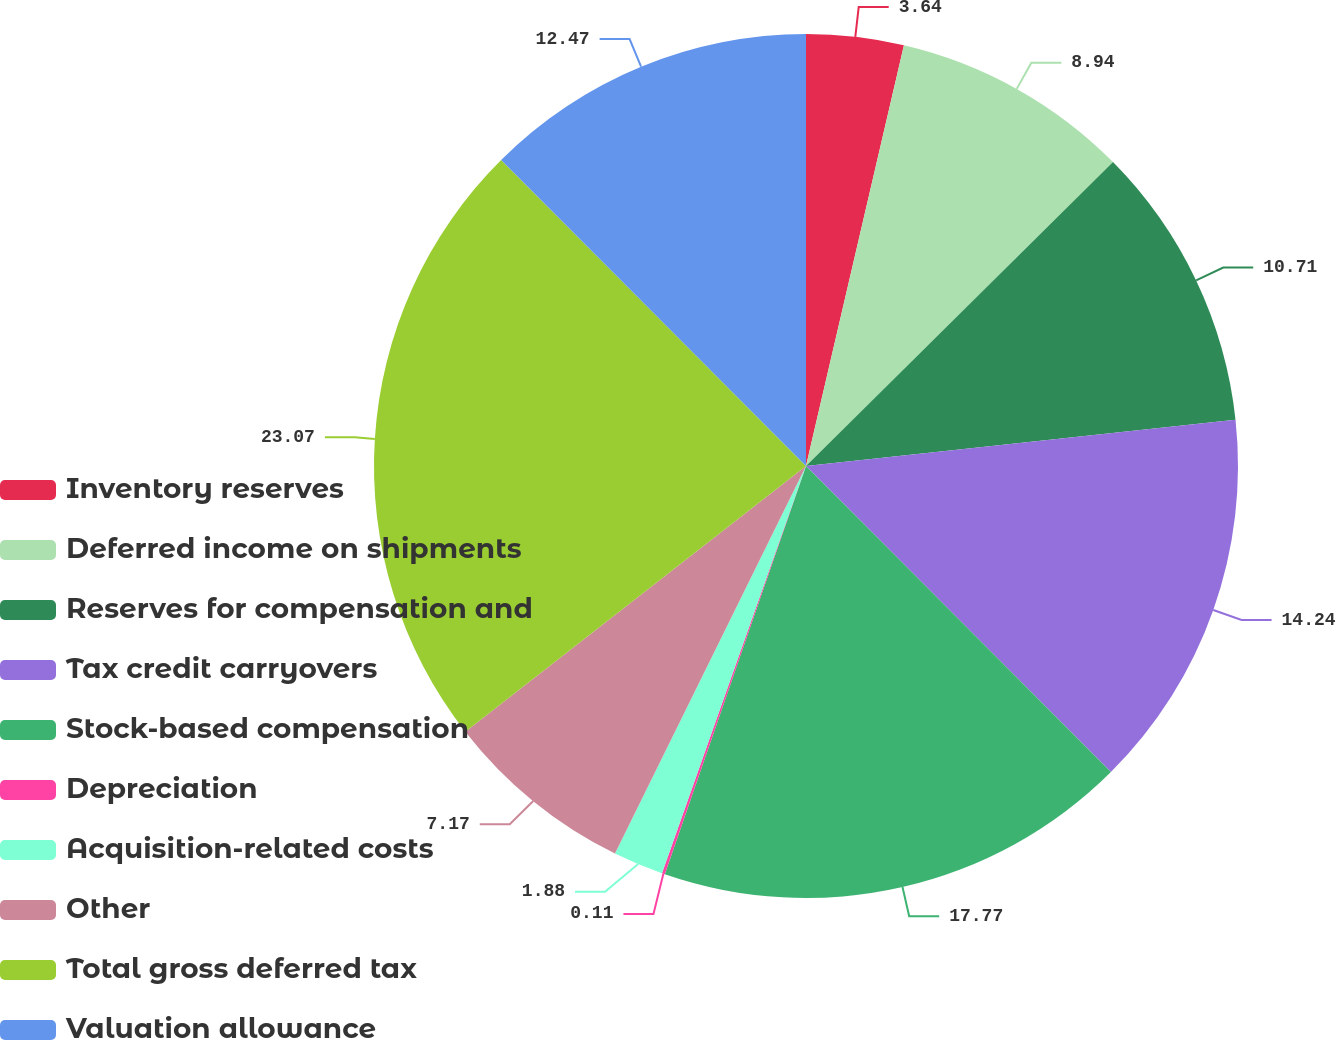Convert chart to OTSL. <chart><loc_0><loc_0><loc_500><loc_500><pie_chart><fcel>Inventory reserves<fcel>Deferred income on shipments<fcel>Reserves for compensation and<fcel>Tax credit carryovers<fcel>Stock-based compensation<fcel>Depreciation<fcel>Acquisition-related costs<fcel>Other<fcel>Total gross deferred tax<fcel>Valuation allowance<nl><fcel>3.64%<fcel>8.94%<fcel>10.71%<fcel>14.24%<fcel>17.77%<fcel>0.11%<fcel>1.88%<fcel>7.17%<fcel>23.07%<fcel>12.47%<nl></chart> 